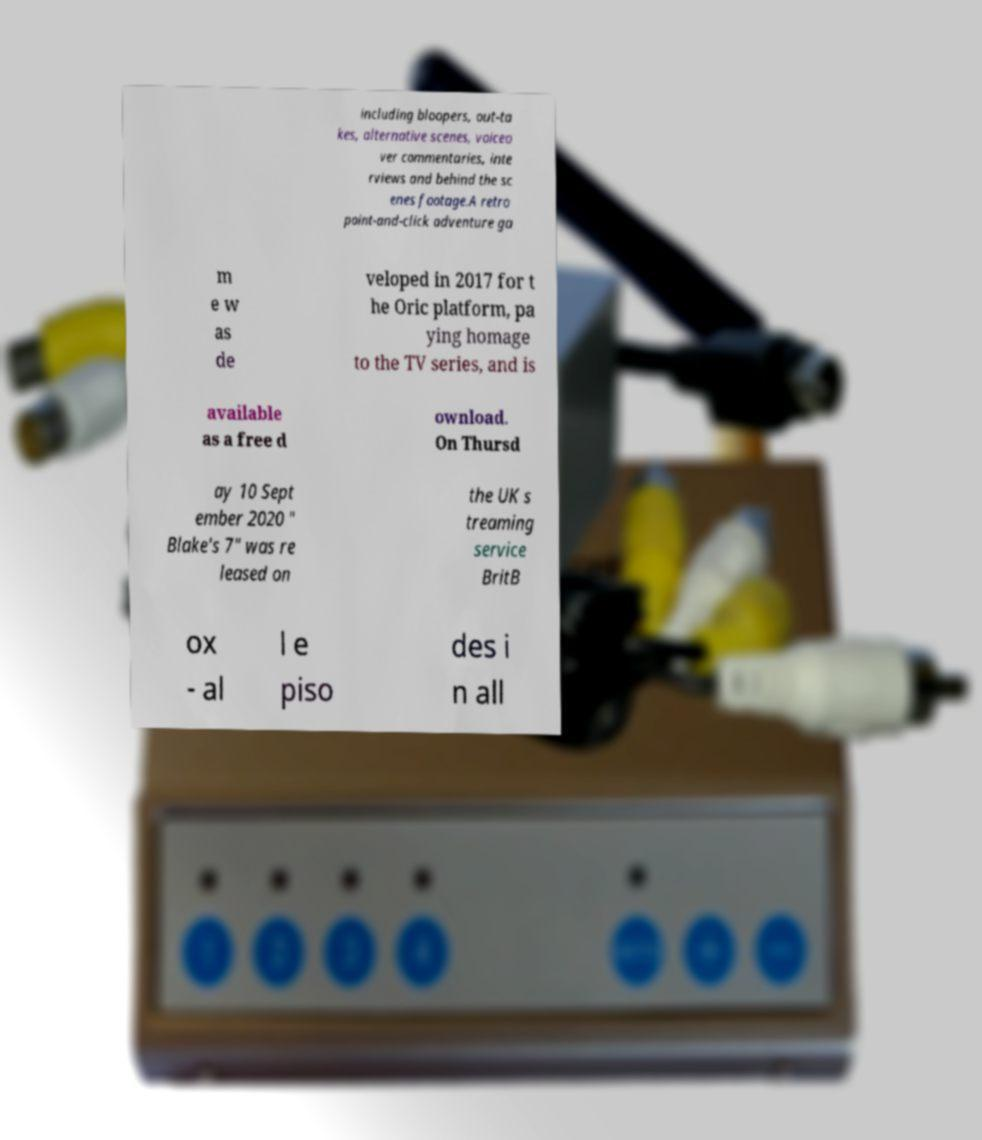I need the written content from this picture converted into text. Can you do that? including bloopers, out-ta kes, alternative scenes, voiceo ver commentaries, inte rviews and behind the sc enes footage.A retro point-and-click adventure ga m e w as de veloped in 2017 for t he Oric platform, pa ying homage to the TV series, and is available as a free d ownload. On Thursd ay 10 Sept ember 2020 " Blake's 7" was re leased on the UK s treaming service BritB ox - al l e piso des i n all 